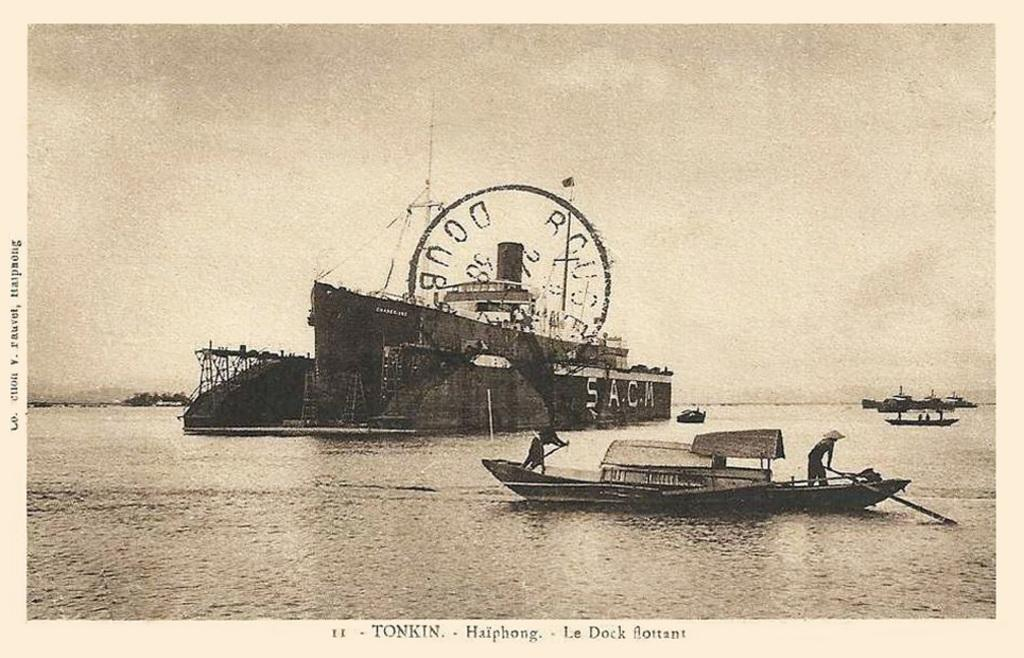What type of image is being described? The image is a poster. What can be seen in the water in the image? There are ships in the water in the image. Where is the text located on the poster? The text is at the bottom of the image. What is the central feature of the poster? There is a stamp in the center of the image. What type of fog can be seen in the alley in the image? There is no fog or alley present in the image; it features a poster with ships in the water, text at the bottom, and a stamp in the center. 